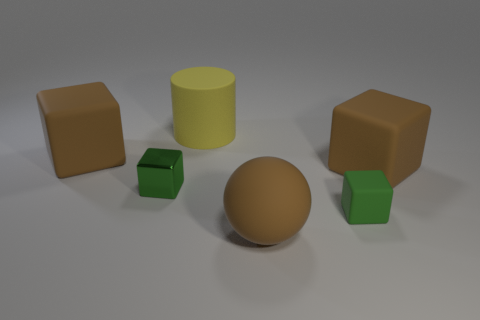There is another cube that is the same size as the green matte block; what is it made of?
Offer a very short reply. Metal. The small block that is on the left side of the tiny green cube that is in front of the green shiny block is what color?
Keep it short and to the point. Green. There is a metallic cube; what number of brown rubber spheres are on the left side of it?
Make the answer very short. 0. What color is the tiny rubber block?
Make the answer very short. Green. How many big objects are green things or green metal objects?
Your response must be concise. 0. Does the matte cube that is in front of the metal block have the same color as the big matte block on the right side of the large cylinder?
Your answer should be compact. No. How many other things are there of the same color as the tiny matte cube?
Keep it short and to the point. 1. What shape is the rubber thing that is on the left side of the yellow rubber cylinder?
Offer a very short reply. Cube. Are there fewer cylinders than large metal things?
Ensure brevity in your answer.  No. Is the tiny block that is to the left of the large matte ball made of the same material as the ball?
Provide a succinct answer. No. 